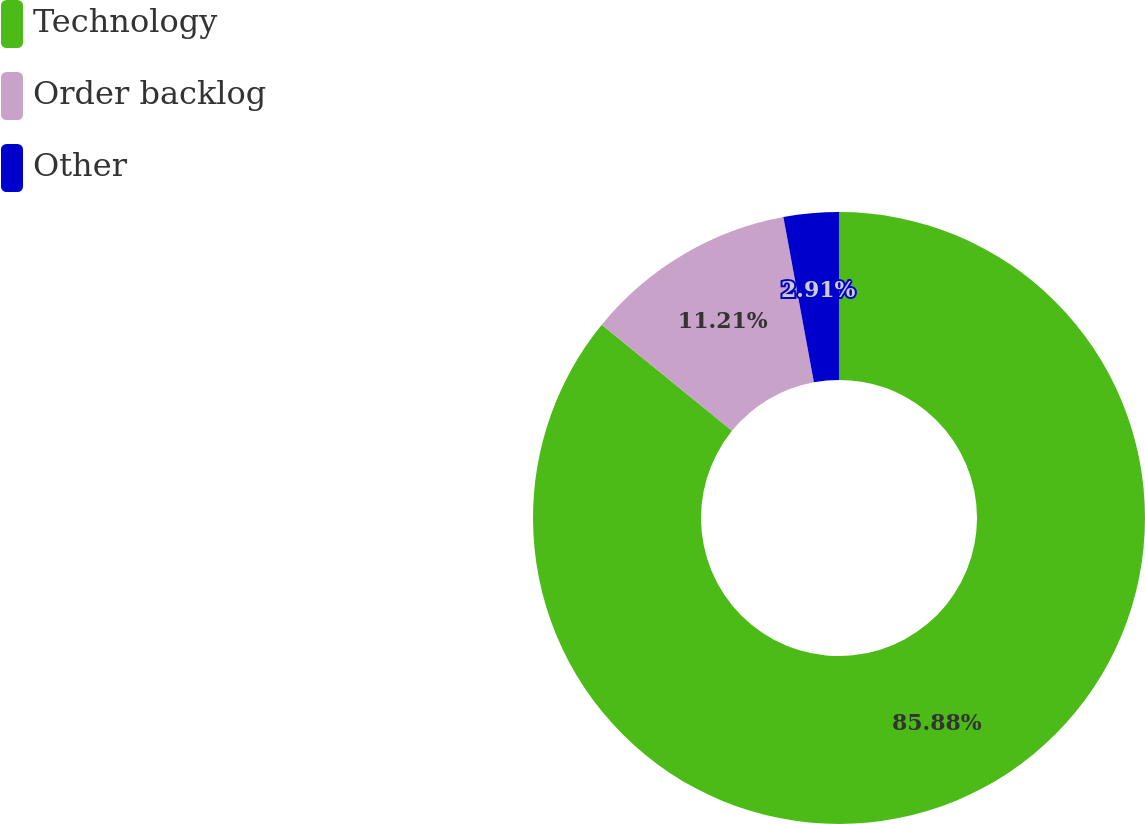Convert chart. <chart><loc_0><loc_0><loc_500><loc_500><pie_chart><fcel>Technology<fcel>Order backlog<fcel>Other<nl><fcel>85.88%<fcel>11.21%<fcel>2.91%<nl></chart> 